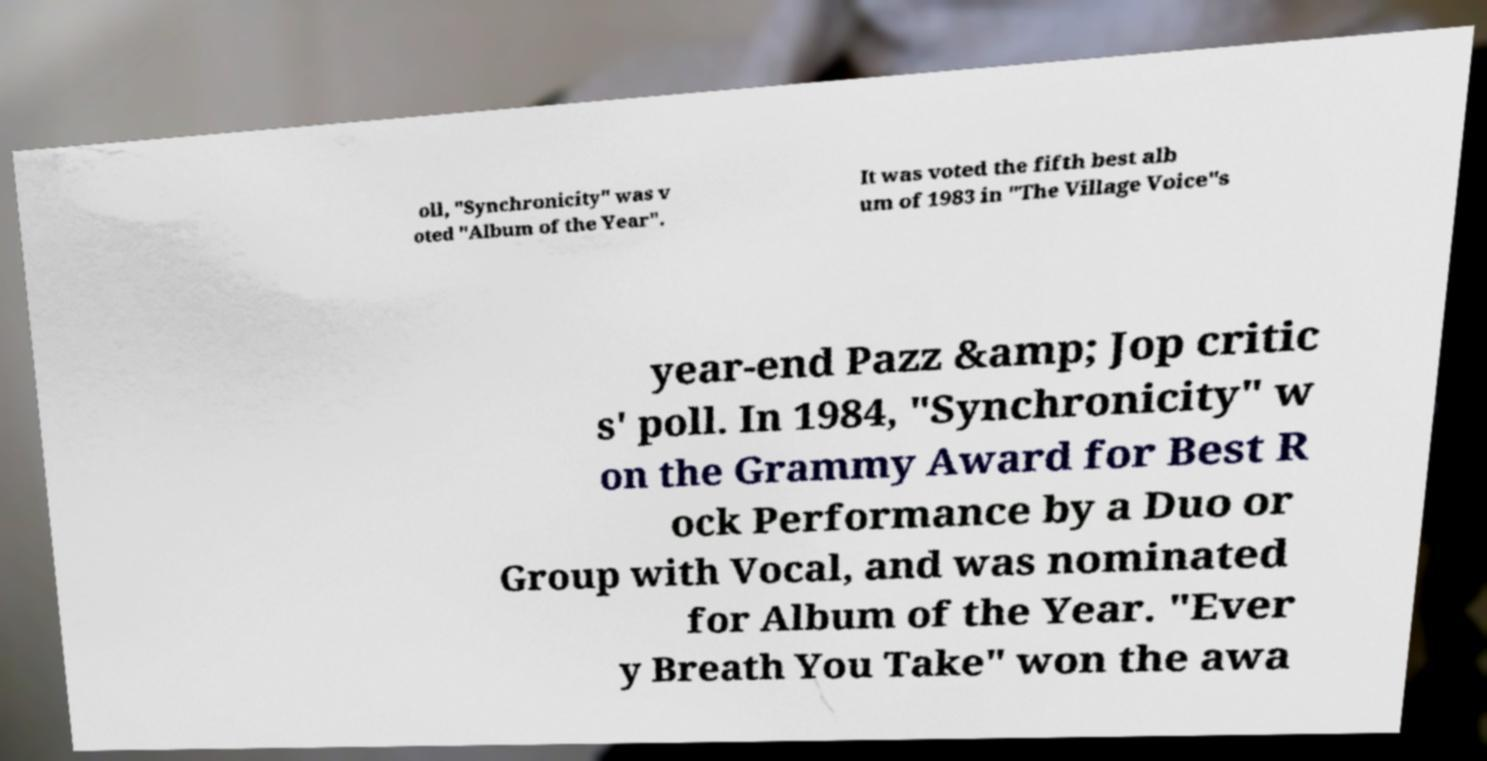Please read and relay the text visible in this image. What does it say? oll, "Synchronicity" was v oted "Album of the Year". It was voted the fifth best alb um of 1983 in "The Village Voice"s year-end Pazz &amp; Jop critic s' poll. In 1984, "Synchronicity" w on the Grammy Award for Best R ock Performance by a Duo or Group with Vocal, and was nominated for Album of the Year. "Ever y Breath You Take" won the awa 